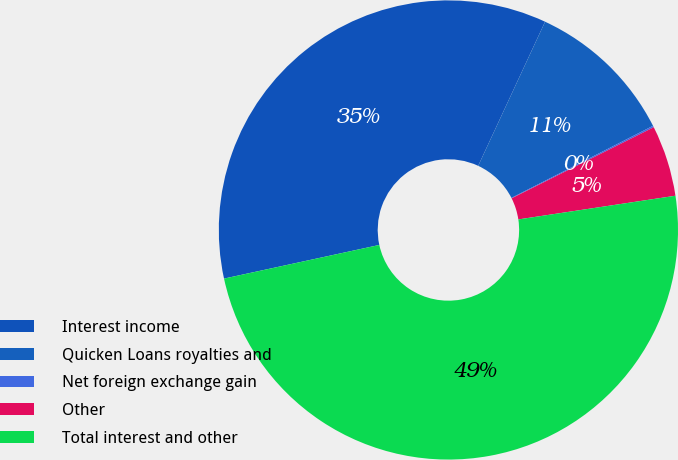Convert chart. <chart><loc_0><loc_0><loc_500><loc_500><pie_chart><fcel>Interest income<fcel>Quicken Loans royalties and<fcel>Net foreign exchange gain<fcel>Other<fcel>Total interest and other<nl><fcel>35.31%<fcel>10.59%<fcel>0.11%<fcel>5.0%<fcel>48.98%<nl></chart> 